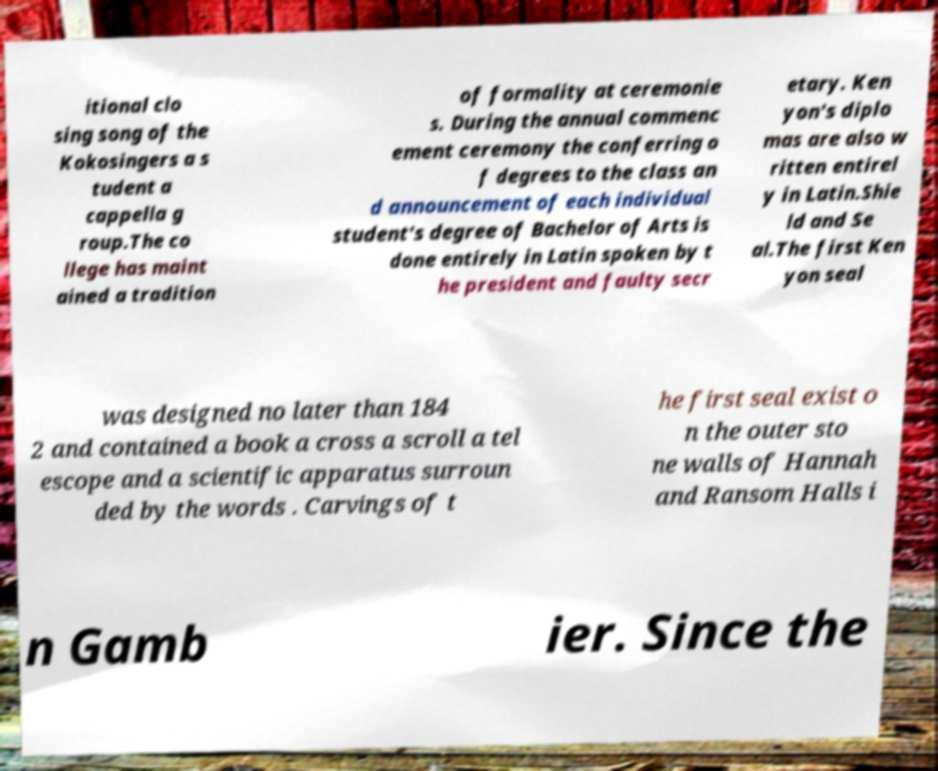Please read and relay the text visible in this image. What does it say? itional clo sing song of the Kokosingers a s tudent a cappella g roup.The co llege has maint ained a tradition of formality at ceremonie s. During the annual commenc ement ceremony the conferring o f degrees to the class an d announcement of each individual student's degree of Bachelor of Arts is done entirely in Latin spoken by t he president and faulty secr etary. Ken yon's diplo mas are also w ritten entirel y in Latin.Shie ld and Se al.The first Ken yon seal was designed no later than 184 2 and contained a book a cross a scroll a tel escope and a scientific apparatus surroun ded by the words . Carvings of t he first seal exist o n the outer sto ne walls of Hannah and Ransom Halls i n Gamb ier. Since the 